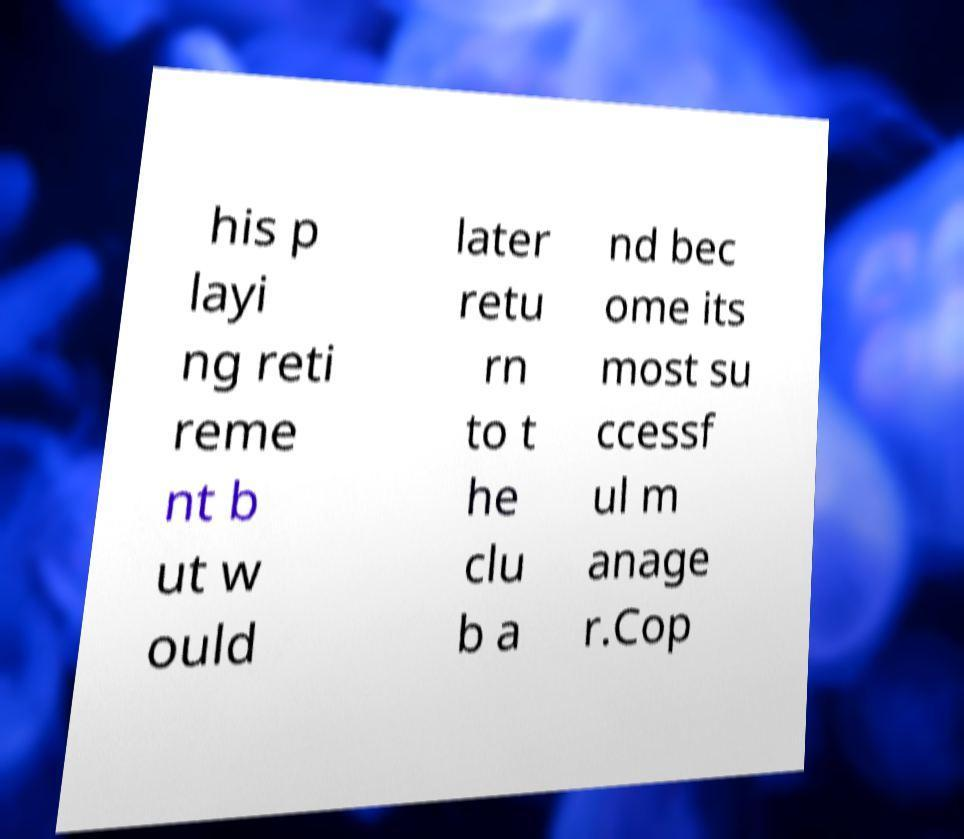For documentation purposes, I need the text within this image transcribed. Could you provide that? his p layi ng reti reme nt b ut w ould later retu rn to t he clu b a nd bec ome its most su ccessf ul m anage r.Cop 